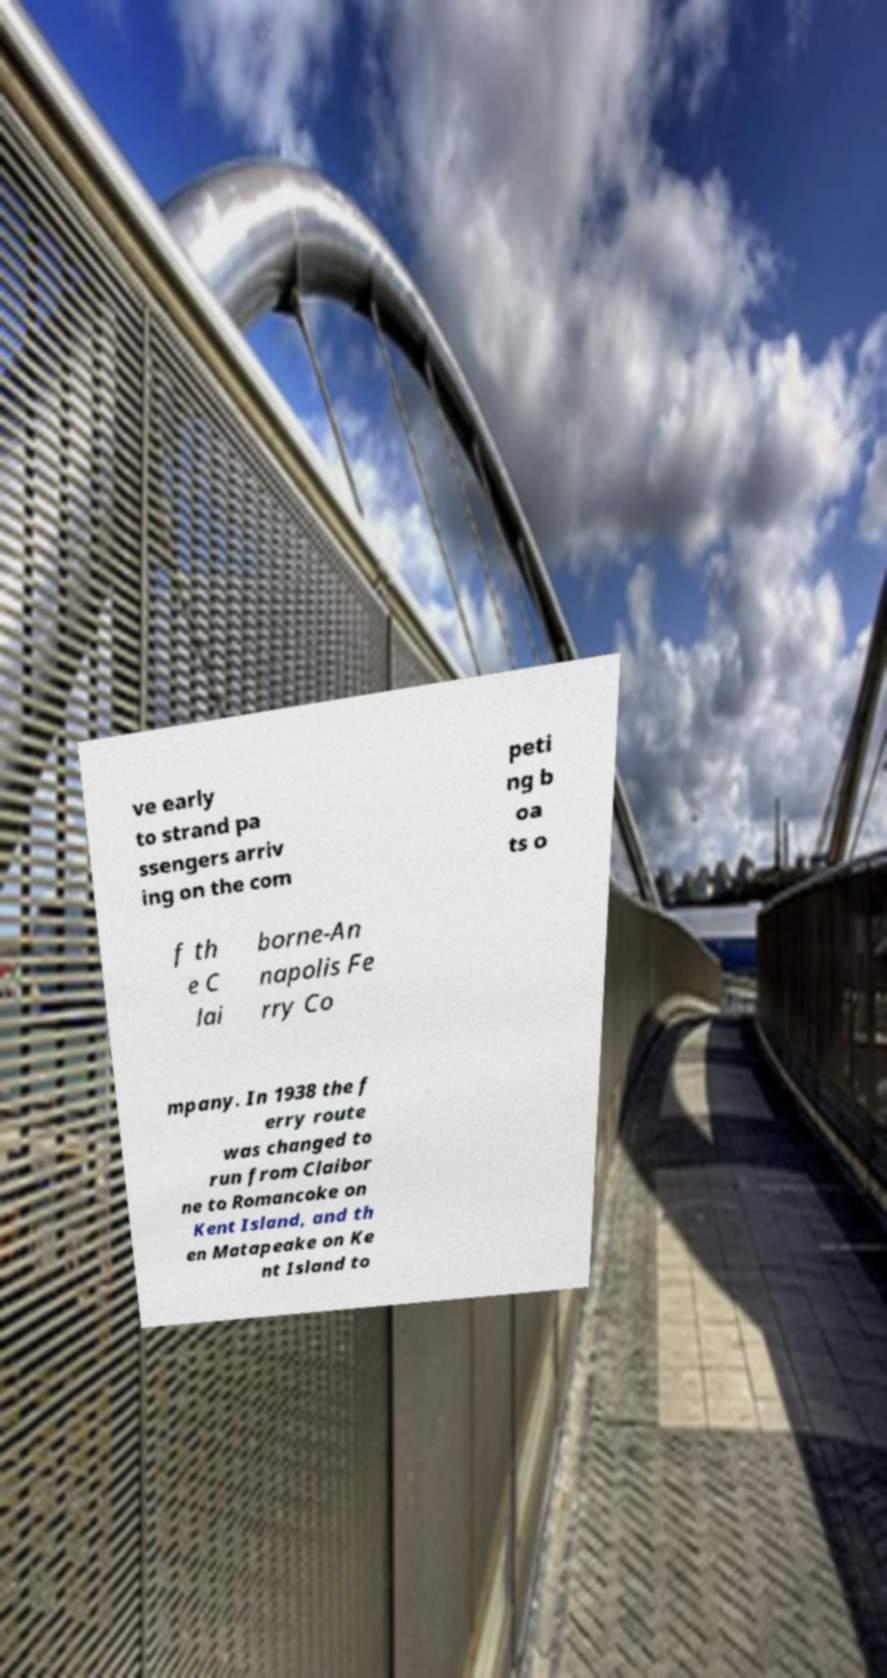What messages or text are displayed in this image? I need them in a readable, typed format. ve early to strand pa ssengers arriv ing on the com peti ng b oa ts o f th e C lai borne-An napolis Fe rry Co mpany. In 1938 the f erry route was changed to run from Claibor ne to Romancoke on Kent Island, and th en Matapeake on Ke nt Island to 